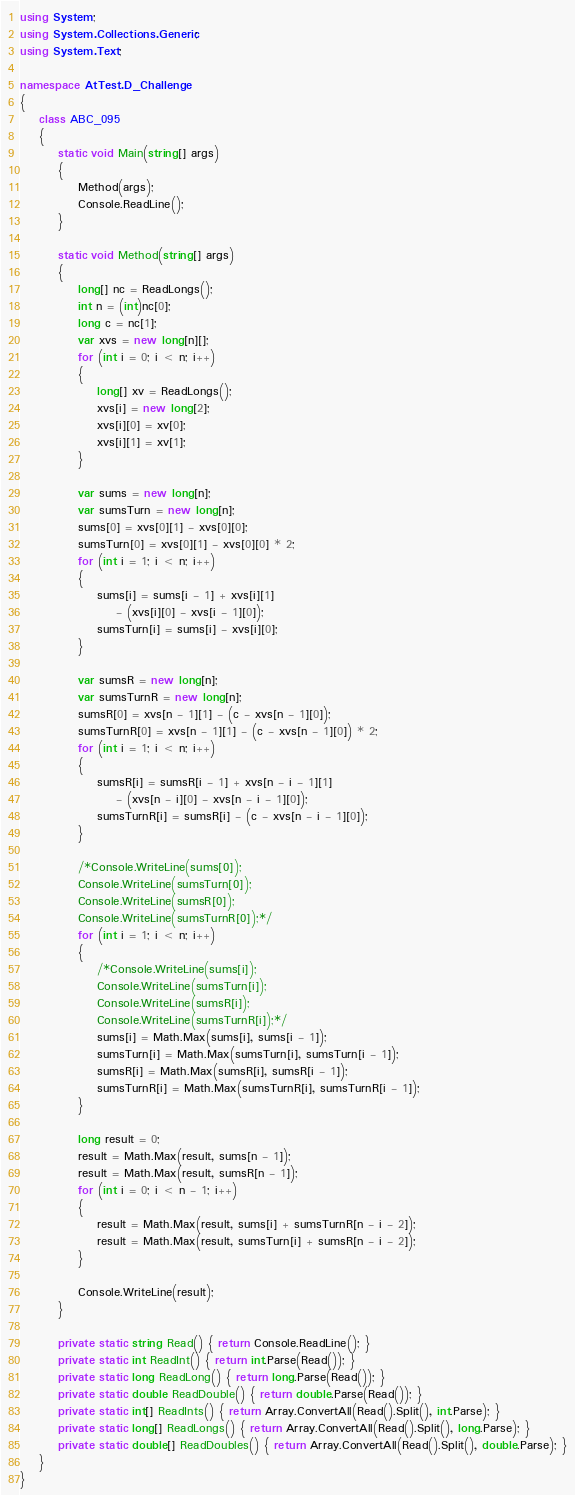Convert code to text. <code><loc_0><loc_0><loc_500><loc_500><_C#_>using System;
using System.Collections.Generic;
using System.Text;

namespace AtTest.D_Challenge
{
    class ABC_095
    {
        static void Main(string[] args)
        {
            Method(args);
            Console.ReadLine();
        }

        static void Method(string[] args)
        {
            long[] nc = ReadLongs();
            int n = (int)nc[0];
            long c = nc[1];
            var xvs = new long[n][];
            for (int i = 0; i < n; i++)
            {
                long[] xv = ReadLongs();
                xvs[i] = new long[2];
                xvs[i][0] = xv[0];
                xvs[i][1] = xv[1];
            }

            var sums = new long[n];
            var sumsTurn = new long[n];
            sums[0] = xvs[0][1] - xvs[0][0];
            sumsTurn[0] = xvs[0][1] - xvs[0][0] * 2;
            for (int i = 1; i < n; i++)
            {
                sums[i] = sums[i - 1] + xvs[i][1]
                    - (xvs[i][0] - xvs[i - 1][0]);
                sumsTurn[i] = sums[i] - xvs[i][0];
            }

            var sumsR = new long[n];
            var sumsTurnR = new long[n];
            sumsR[0] = xvs[n - 1][1] - (c - xvs[n - 1][0]);
            sumsTurnR[0] = xvs[n - 1][1] - (c - xvs[n - 1][0]) * 2;
            for (int i = 1; i < n; i++)
            {
                sumsR[i] = sumsR[i - 1] + xvs[n - i - 1][1]
                    - (xvs[n - i][0] - xvs[n - i - 1][0]);
                sumsTurnR[i] = sumsR[i] - (c - xvs[n - i - 1][0]);
            }

            /*Console.WriteLine(sums[0]);
            Console.WriteLine(sumsTurn[0]);
            Console.WriteLine(sumsR[0]);
            Console.WriteLine(sumsTurnR[0]);*/
            for (int i = 1; i < n; i++)
            {
                /*Console.WriteLine(sums[i]);
                Console.WriteLine(sumsTurn[i]);
                Console.WriteLine(sumsR[i]);
                Console.WriteLine(sumsTurnR[i]);*/
                sums[i] = Math.Max(sums[i], sums[i - 1]);
                sumsTurn[i] = Math.Max(sumsTurn[i], sumsTurn[i - 1]);
                sumsR[i] = Math.Max(sumsR[i], sumsR[i - 1]);
                sumsTurnR[i] = Math.Max(sumsTurnR[i], sumsTurnR[i - 1]);
            }

            long result = 0;
            result = Math.Max(result, sums[n - 1]);
            result = Math.Max(result, sumsR[n - 1]);
            for (int i = 0; i < n - 1; i++)
            {
                result = Math.Max(result, sums[i] + sumsTurnR[n - i - 2]);
                result = Math.Max(result, sumsTurn[i] + sumsR[n - i - 2]);
            }

            Console.WriteLine(result);
        }

        private static string Read() { return Console.ReadLine(); }
        private static int ReadInt() { return int.Parse(Read()); }
        private static long ReadLong() { return long.Parse(Read()); }
        private static double ReadDouble() { return double.Parse(Read()); }
        private static int[] ReadInts() { return Array.ConvertAll(Read().Split(), int.Parse); }
        private static long[] ReadLongs() { return Array.ConvertAll(Read().Split(), long.Parse); }
        private static double[] ReadDoubles() { return Array.ConvertAll(Read().Split(), double.Parse); }
    }
}
</code> 